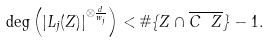Convert formula to latex. <formula><loc_0><loc_0><loc_500><loc_500>\deg \left ( | L _ { j } ( Z ) | ^ { \otimes \frac { d } { w _ { j } } } \right ) < \# \{ Z \cap \overline { C \ Z } \} - 1 .</formula> 